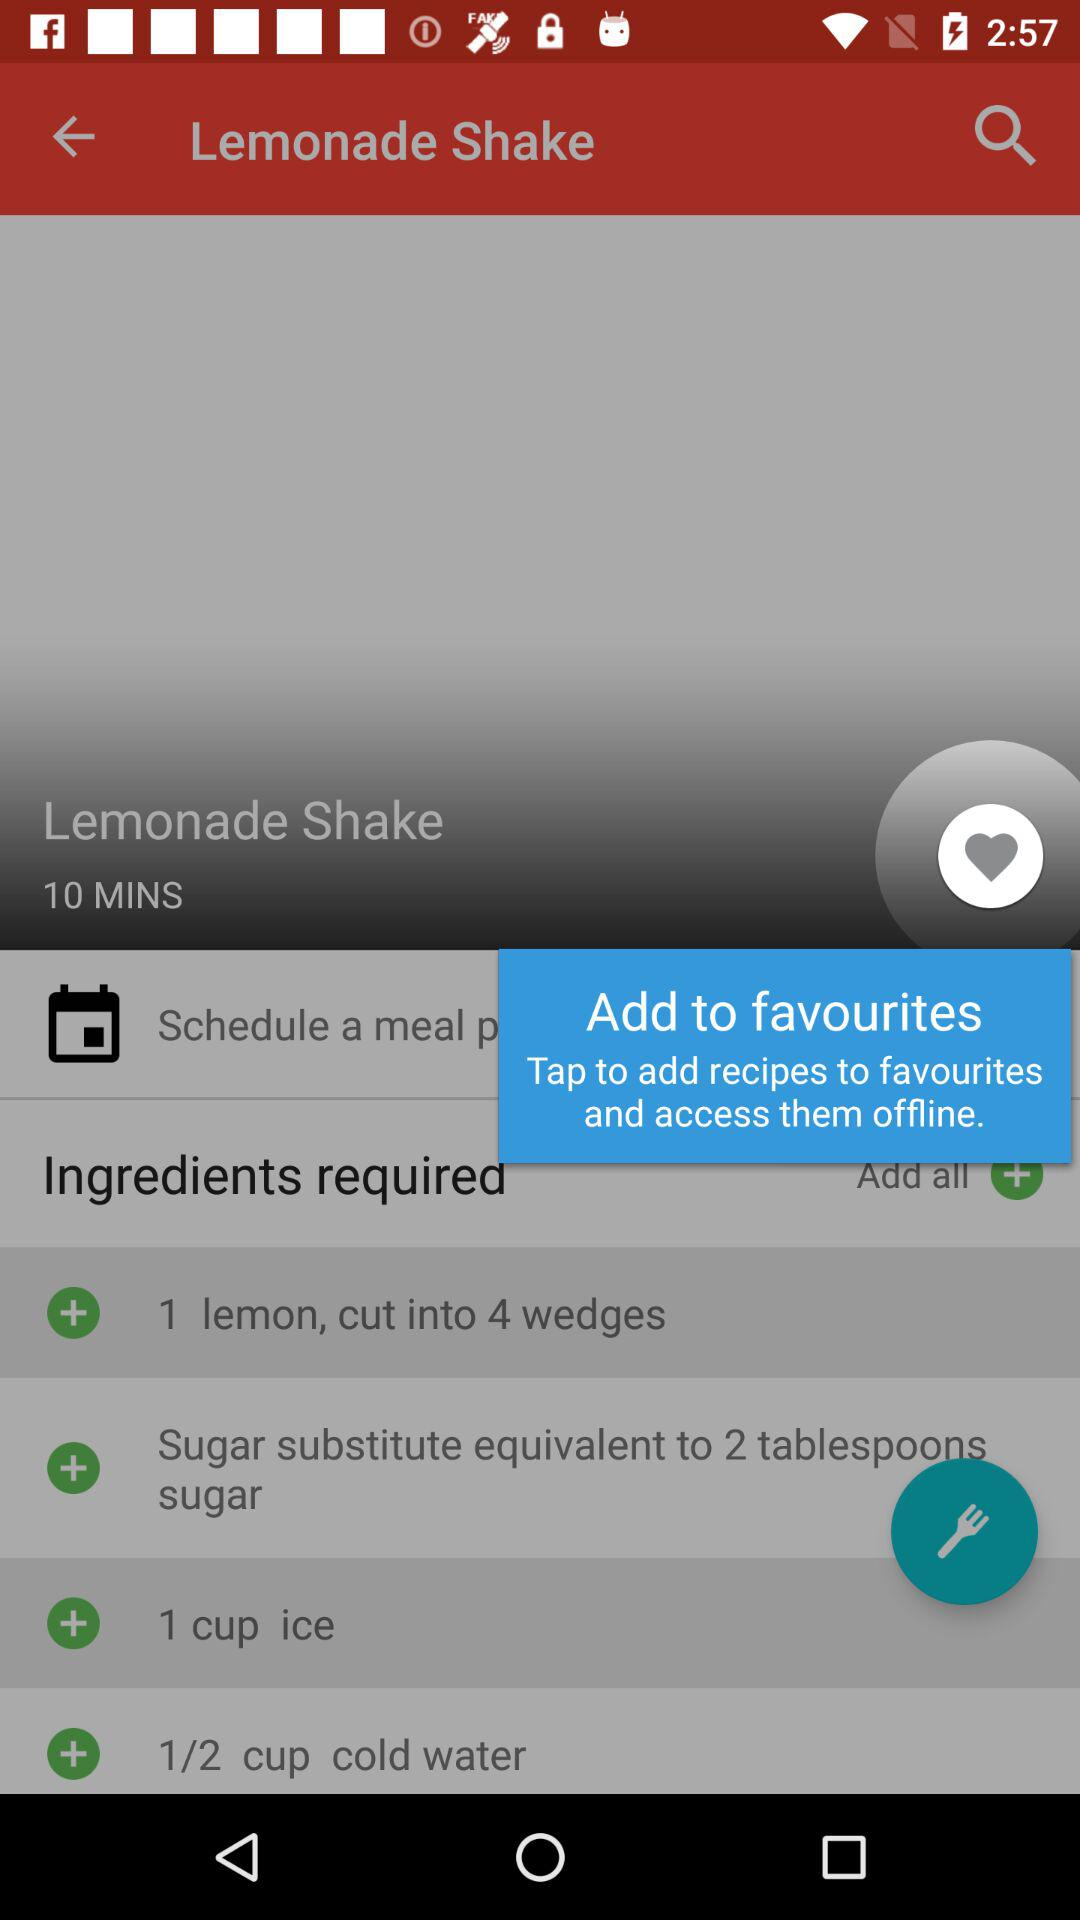How much sugar substitute is required to make the lemonade shake?
Answer the question using a single word or phrase. 2 tablespoons 